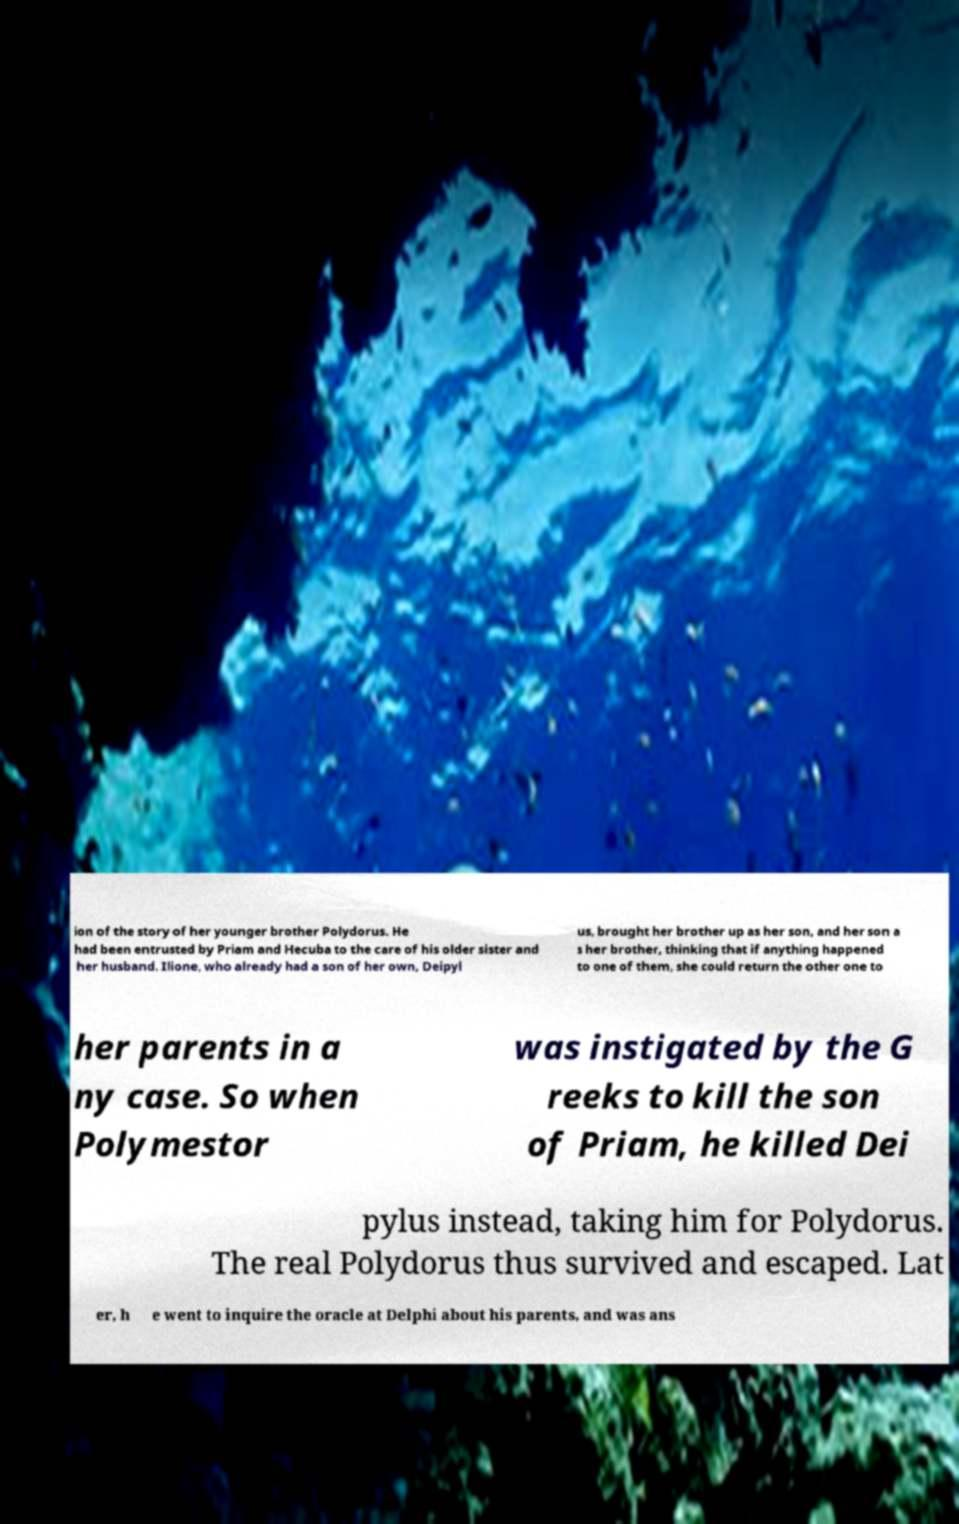There's text embedded in this image that I need extracted. Can you transcribe it verbatim? ion of the story of her younger brother Polydorus. He had been entrusted by Priam and Hecuba to the care of his older sister and her husband. Ilione, who already had a son of her own, Deipyl us, brought her brother up as her son, and her son a s her brother, thinking that if anything happened to one of them, she could return the other one to her parents in a ny case. So when Polymestor was instigated by the G reeks to kill the son of Priam, he killed Dei pylus instead, taking him for Polydorus. The real Polydorus thus survived and escaped. Lat er, h e went to inquire the oracle at Delphi about his parents, and was ans 